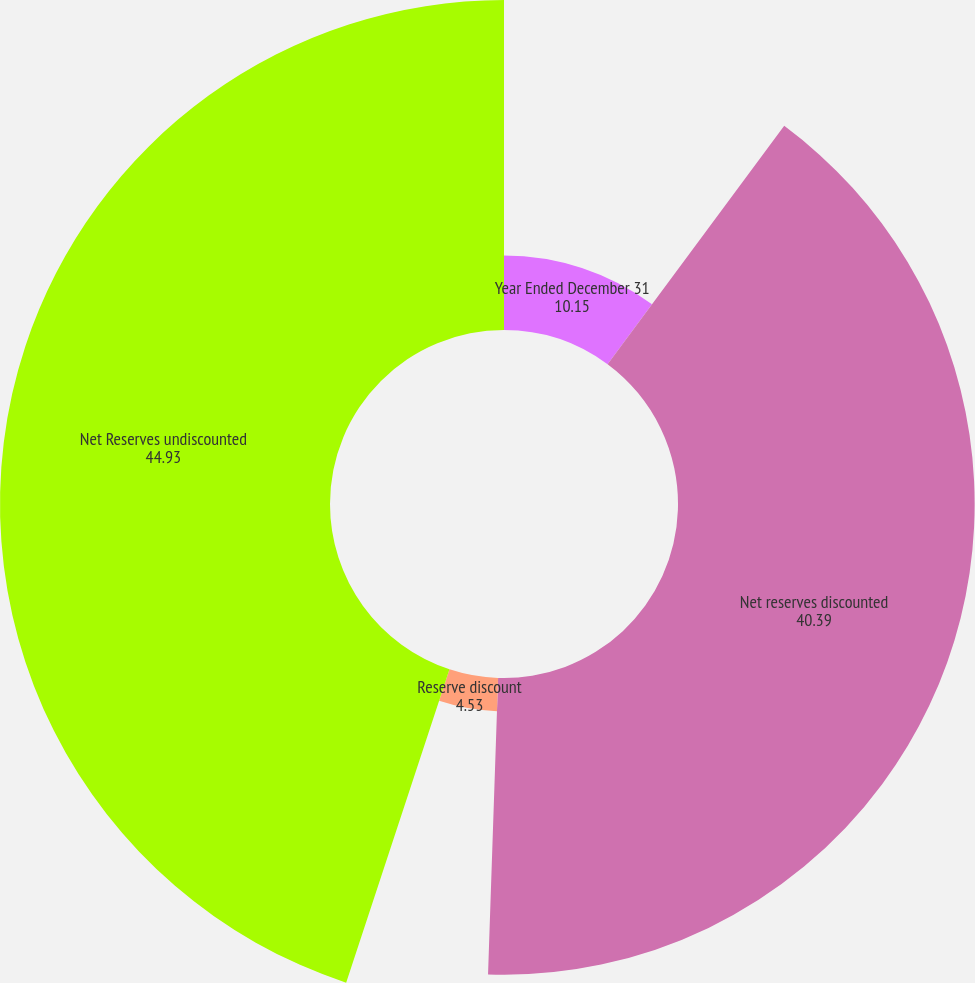<chart> <loc_0><loc_0><loc_500><loc_500><pie_chart><fcel>Year Ended December 31<fcel>Net reserves discounted<fcel>Reserve discount<fcel>Net Reserves undiscounted<nl><fcel>10.15%<fcel>40.39%<fcel>4.53%<fcel>44.93%<nl></chart> 